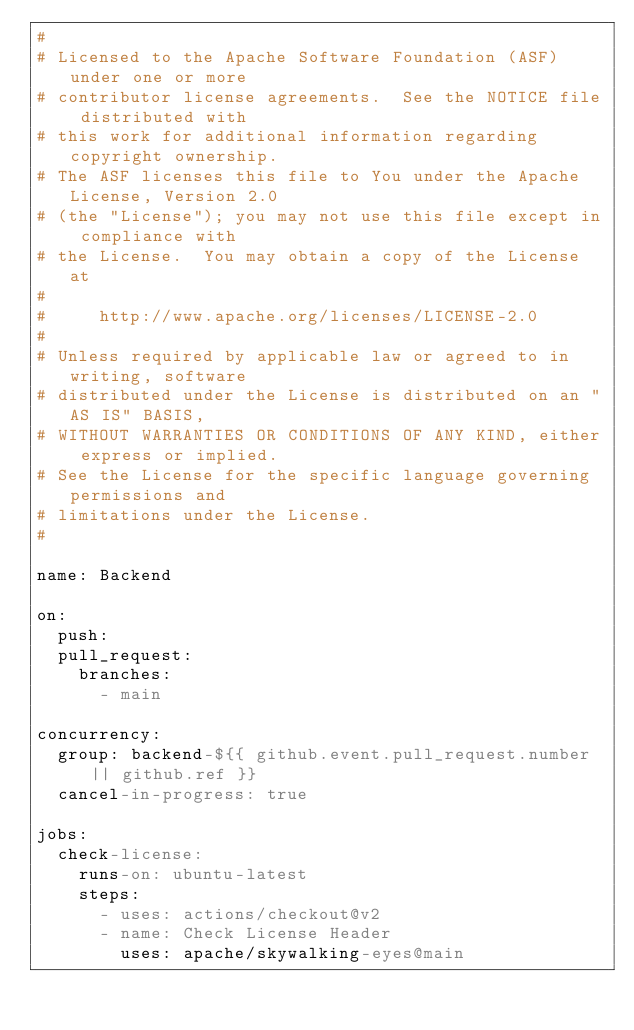Convert code to text. <code><loc_0><loc_0><loc_500><loc_500><_YAML_>#
# Licensed to the Apache Software Foundation (ASF) under one or more
# contributor license agreements.  See the NOTICE file distributed with
# this work for additional information regarding copyright ownership.
# The ASF licenses this file to You under the Apache License, Version 2.0
# (the "License"); you may not use this file except in compliance with
# the License.  You may obtain a copy of the License at
#
#     http://www.apache.org/licenses/LICENSE-2.0
#
# Unless required by applicable law or agreed to in writing, software
# distributed under the License is distributed on an "AS IS" BASIS,
# WITHOUT WARRANTIES OR CONDITIONS OF ANY KIND, either express or implied.
# See the License for the specific language governing permissions and
# limitations under the License.
#

name: Backend

on:
  push:
  pull_request:
    branches:
      - main

concurrency:
  group: backend-${{ github.event.pull_request.number || github.ref }}
  cancel-in-progress: true

jobs:
  check-license:
    runs-on: ubuntu-latest
    steps:
      - uses: actions/checkout@v2
      - name: Check License Header
        uses: apache/skywalking-eyes@main
</code> 